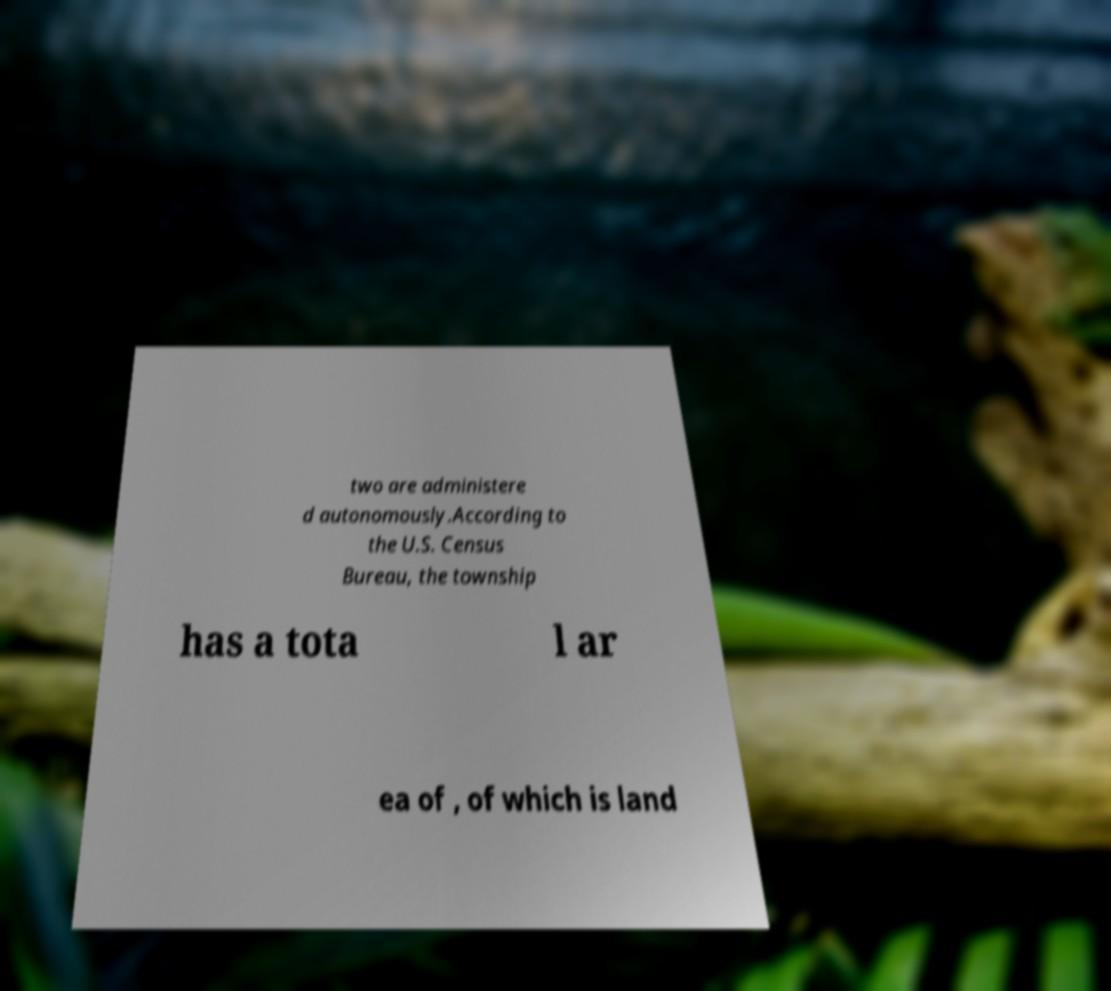For documentation purposes, I need the text within this image transcribed. Could you provide that? two are administere d autonomously.According to the U.S. Census Bureau, the township has a tota l ar ea of , of which is land 